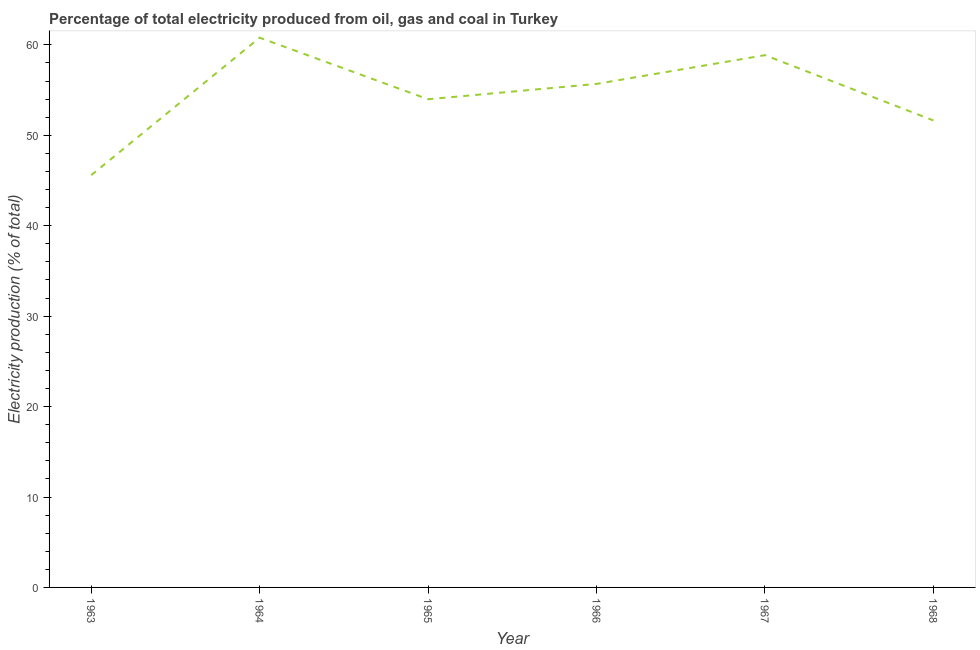What is the electricity production in 1967?
Keep it short and to the point. 58.86. Across all years, what is the maximum electricity production?
Make the answer very short. 60.8. Across all years, what is the minimum electricity production?
Your answer should be compact. 45.59. In which year was the electricity production maximum?
Ensure brevity in your answer.  1964. In which year was the electricity production minimum?
Your response must be concise. 1963. What is the sum of the electricity production?
Offer a terse response. 326.57. What is the difference between the electricity production in 1964 and 1965?
Make the answer very short. 6.81. What is the average electricity production per year?
Your answer should be compact. 54.43. What is the median electricity production?
Make the answer very short. 54.84. What is the ratio of the electricity production in 1963 to that in 1966?
Your answer should be compact. 0.82. Is the electricity production in 1963 less than that in 1965?
Your answer should be very brief. Yes. Is the difference between the electricity production in 1966 and 1968 greater than the difference between any two years?
Keep it short and to the point. No. What is the difference between the highest and the second highest electricity production?
Your answer should be compact. 1.93. What is the difference between the highest and the lowest electricity production?
Your answer should be very brief. 15.2. How many lines are there?
Keep it short and to the point. 1. What is the difference between two consecutive major ticks on the Y-axis?
Make the answer very short. 10. Are the values on the major ticks of Y-axis written in scientific E-notation?
Your response must be concise. No. Does the graph contain grids?
Your response must be concise. No. What is the title of the graph?
Your response must be concise. Percentage of total electricity produced from oil, gas and coal in Turkey. What is the label or title of the X-axis?
Provide a succinct answer. Year. What is the label or title of the Y-axis?
Keep it short and to the point. Electricity production (% of total). What is the Electricity production (% of total) of 1963?
Keep it short and to the point. 45.59. What is the Electricity production (% of total) in 1964?
Your answer should be very brief. 60.8. What is the Electricity production (% of total) of 1965?
Ensure brevity in your answer.  53.99. What is the Electricity production (% of total) in 1966?
Your answer should be very brief. 55.68. What is the Electricity production (% of total) of 1967?
Your response must be concise. 58.86. What is the Electricity production (% of total) of 1968?
Your answer should be very brief. 51.64. What is the difference between the Electricity production (% of total) in 1963 and 1964?
Your answer should be very brief. -15.2. What is the difference between the Electricity production (% of total) in 1963 and 1965?
Ensure brevity in your answer.  -8.39. What is the difference between the Electricity production (% of total) in 1963 and 1966?
Your answer should be compact. -10.09. What is the difference between the Electricity production (% of total) in 1963 and 1967?
Provide a succinct answer. -13.27. What is the difference between the Electricity production (% of total) in 1963 and 1968?
Give a very brief answer. -6.05. What is the difference between the Electricity production (% of total) in 1964 and 1965?
Make the answer very short. 6.81. What is the difference between the Electricity production (% of total) in 1964 and 1966?
Your answer should be very brief. 5.11. What is the difference between the Electricity production (% of total) in 1964 and 1967?
Provide a short and direct response. 1.93. What is the difference between the Electricity production (% of total) in 1964 and 1968?
Offer a terse response. 9.15. What is the difference between the Electricity production (% of total) in 1965 and 1966?
Keep it short and to the point. -1.7. What is the difference between the Electricity production (% of total) in 1965 and 1967?
Offer a very short reply. -4.88. What is the difference between the Electricity production (% of total) in 1965 and 1968?
Your answer should be very brief. 2.34. What is the difference between the Electricity production (% of total) in 1966 and 1967?
Offer a very short reply. -3.18. What is the difference between the Electricity production (% of total) in 1966 and 1968?
Offer a terse response. 4.04. What is the difference between the Electricity production (% of total) in 1967 and 1968?
Your response must be concise. 7.22. What is the ratio of the Electricity production (% of total) in 1963 to that in 1965?
Your answer should be very brief. 0.84. What is the ratio of the Electricity production (% of total) in 1963 to that in 1966?
Keep it short and to the point. 0.82. What is the ratio of the Electricity production (% of total) in 1963 to that in 1967?
Your answer should be compact. 0.78. What is the ratio of the Electricity production (% of total) in 1963 to that in 1968?
Offer a terse response. 0.88. What is the ratio of the Electricity production (% of total) in 1964 to that in 1965?
Give a very brief answer. 1.13. What is the ratio of the Electricity production (% of total) in 1964 to that in 1966?
Your answer should be very brief. 1.09. What is the ratio of the Electricity production (% of total) in 1964 to that in 1967?
Ensure brevity in your answer.  1.03. What is the ratio of the Electricity production (% of total) in 1964 to that in 1968?
Your answer should be very brief. 1.18. What is the ratio of the Electricity production (% of total) in 1965 to that in 1967?
Offer a very short reply. 0.92. What is the ratio of the Electricity production (% of total) in 1965 to that in 1968?
Provide a short and direct response. 1.04. What is the ratio of the Electricity production (% of total) in 1966 to that in 1967?
Your answer should be compact. 0.95. What is the ratio of the Electricity production (% of total) in 1966 to that in 1968?
Your response must be concise. 1.08. What is the ratio of the Electricity production (% of total) in 1967 to that in 1968?
Your answer should be very brief. 1.14. 